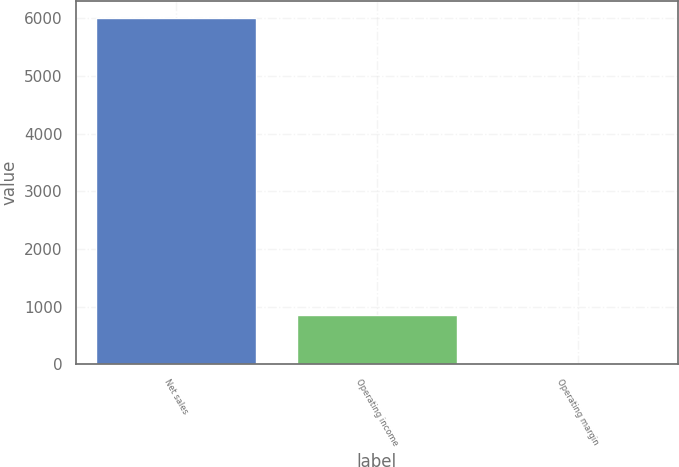Convert chart to OTSL. <chart><loc_0><loc_0><loc_500><loc_500><bar_chart><fcel>Net sales<fcel>Operating income<fcel>Operating margin<nl><fcel>6007<fcel>847<fcel>14.1<nl></chart> 